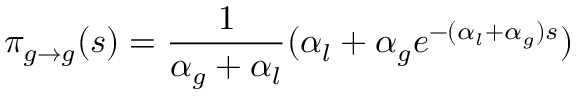<formula> <loc_0><loc_0><loc_500><loc_500>\pi _ { g \to g } ( s ) = \frac { 1 } { \alpha _ { g } + \alpha _ { l } } ( \alpha _ { l } + \alpha _ { g } e ^ { - ( \alpha _ { l } + \alpha _ { g } ) s } )</formula> 